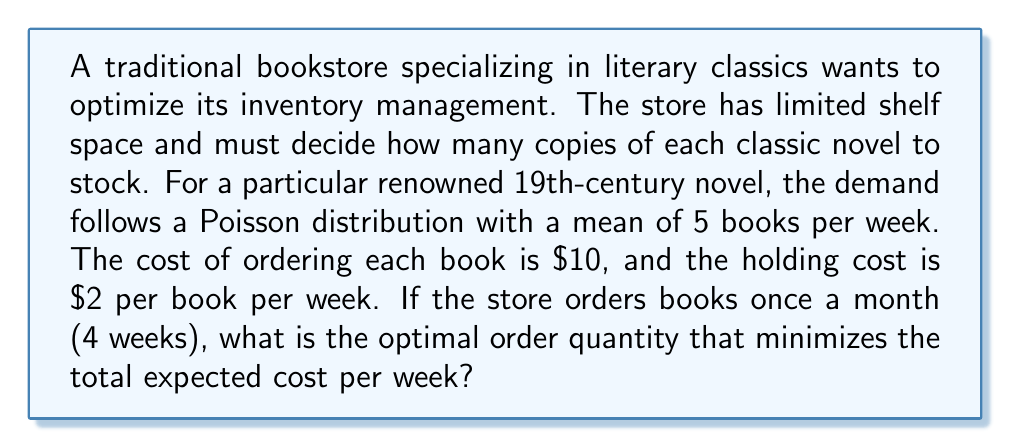Could you help me with this problem? To solve this problem, we'll use the Economic Order Quantity (EOQ) model with a modification for the Poisson-distributed demand. Let's break it down step by step:

1. Given information:
   - Demand (D) follows a Poisson distribution with mean λ = 5 books per week
   - Ordering cost (K) = $10 per order
   - Holding cost (h) = $2 per book per week
   - Order cycle (T) = 4 weeks

2. For a Poisson distribution, the variance equals the mean. So, σ² = λ = 5

3. The optimal order quantity (Q*) for a variable demand can be approximated using the following formula:

   $$Q^* = \sqrt{\frac{2KD}{h} + \frac{z^2\sigma^2}{4}}$$

   Where z is the safety factor (we'll use z = 1.645 for a 95% service level)

4. Calculate the components:
   - D = λT = 5 * 4 = 20 books per month
   - $$\frac{2KD}{h} = \frac{2 * 10 * 20}{2} = 200$$
   - $$\frac{z^2\sigma^2}{4} = \frac{1.645^2 * 5 * 4}{4} = 13.55$$

5. Plug these values into the formula:

   $$Q^* = \sqrt{200 + 13.55} = \sqrt{213.55} = 14.61$$

6. Since we can only order whole books, we round to the nearest integer: 15 books

To verify this is the optimal quantity, we can calculate the total expected cost per week for Q = 14, 15, and 16:

For Q books:
- Ordering cost per week: $K * (D/Q) / T$
- Holding cost per week: $h * Q / 2$
- Total cost per week: $TC(Q) = (K * (D/Q) / T) + (h * Q / 2)$

$$TC(14) = (10 * (20/14) / 4) + (2 * 14 / 2) = 3.57 + 14 = 17.57$$
$$TC(15) = (10 * (20/15) / 4) + (2 * 15 / 2) = 3.33 + 15 = 18.33$$
$$TC(16) = (10 * (20/16) / 4) + (2 * 16 / 2) = 3.13 + 16 = 19.13$$

The minimum total cost is achieved at Q = 15 books.
Answer: The optimal order quantity is 15 books. 